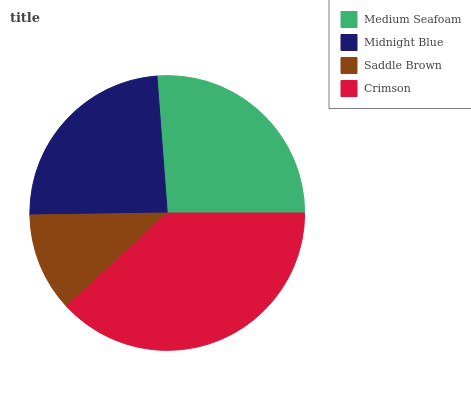Is Saddle Brown the minimum?
Answer yes or no. Yes. Is Crimson the maximum?
Answer yes or no. Yes. Is Midnight Blue the minimum?
Answer yes or no. No. Is Midnight Blue the maximum?
Answer yes or no. No. Is Medium Seafoam greater than Midnight Blue?
Answer yes or no. Yes. Is Midnight Blue less than Medium Seafoam?
Answer yes or no. Yes. Is Midnight Blue greater than Medium Seafoam?
Answer yes or no. No. Is Medium Seafoam less than Midnight Blue?
Answer yes or no. No. Is Medium Seafoam the high median?
Answer yes or no. Yes. Is Midnight Blue the low median?
Answer yes or no. Yes. Is Crimson the high median?
Answer yes or no. No. Is Crimson the low median?
Answer yes or no. No. 